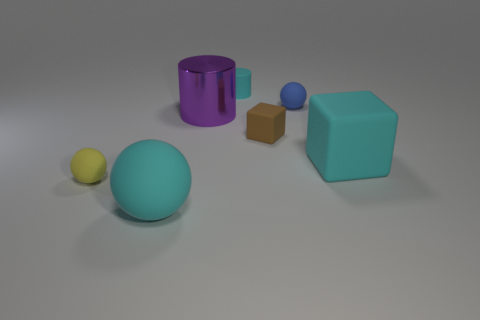The purple object that is the same shape as the small cyan matte object is what size?
Provide a succinct answer. Large. What number of things are big purple metallic spheres or big cyan objects that are right of the yellow rubber object?
Keep it short and to the point. 2. What shape is the small yellow rubber thing?
Offer a very short reply. Sphere. The big cyan thing that is behind the small object that is in front of the tiny brown rubber block is what shape?
Make the answer very short. Cube. There is a large block that is the same color as the small cylinder; what is it made of?
Provide a short and direct response. Rubber. What color is the cylinder that is made of the same material as the brown object?
Your answer should be very brief. Cyan. Is the color of the large matte thing that is on the right side of the brown cube the same as the big ball on the left side of the tiny blue thing?
Make the answer very short. Yes. Are there more small rubber balls to the right of the small brown rubber block than big objects behind the tiny yellow matte object?
Provide a short and direct response. No. What color is the tiny matte thing that is the same shape as the purple metal object?
Provide a short and direct response. Cyan. Is there anything else that is the same shape as the big purple metallic object?
Offer a terse response. Yes. 